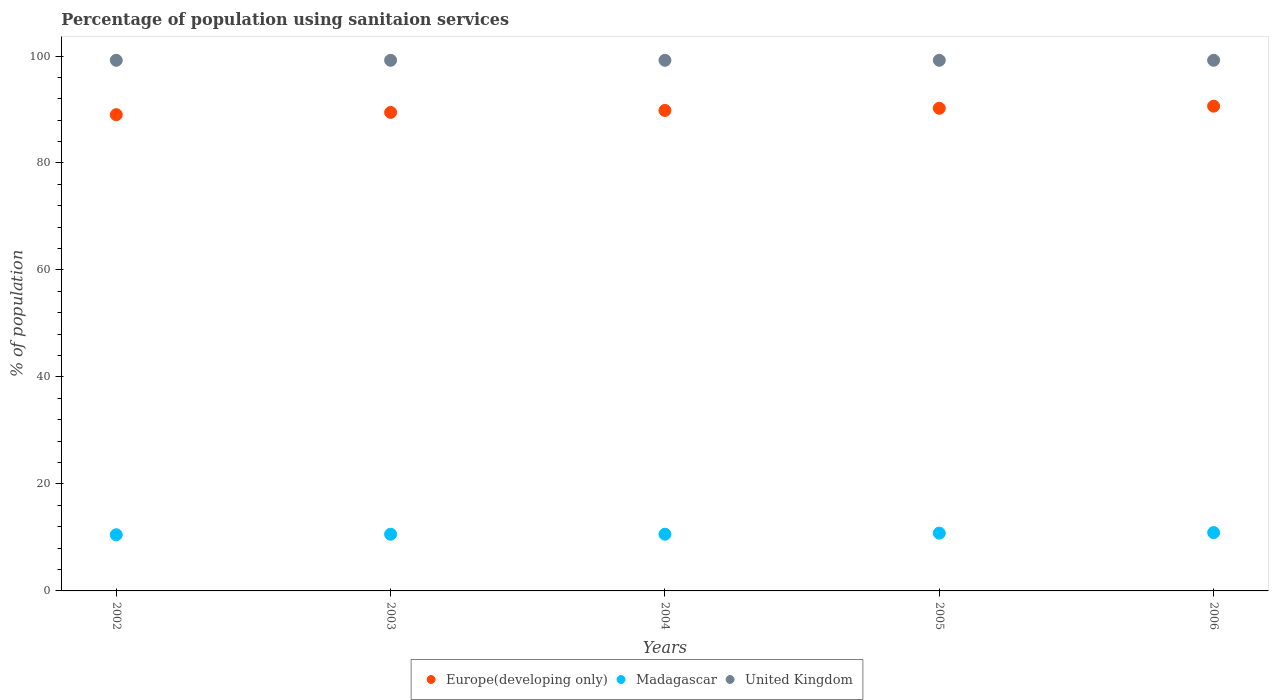How many different coloured dotlines are there?
Your answer should be very brief. 3. What is the percentage of population using sanitaion services in United Kingdom in 2006?
Give a very brief answer. 99.2. Across all years, what is the maximum percentage of population using sanitaion services in Europe(developing only)?
Your response must be concise. 90.63. Across all years, what is the minimum percentage of population using sanitaion services in Europe(developing only)?
Offer a very short reply. 89.03. In which year was the percentage of population using sanitaion services in Madagascar minimum?
Your answer should be compact. 2002. What is the total percentage of population using sanitaion services in United Kingdom in the graph?
Offer a very short reply. 496. What is the difference between the percentage of population using sanitaion services in Madagascar in 2002 and that in 2004?
Keep it short and to the point. -0.1. What is the difference between the percentage of population using sanitaion services in Europe(developing only) in 2006 and the percentage of population using sanitaion services in Madagascar in 2004?
Give a very brief answer. 80.03. What is the average percentage of population using sanitaion services in Madagascar per year?
Your answer should be very brief. 10.68. In the year 2006, what is the difference between the percentage of population using sanitaion services in Madagascar and percentage of population using sanitaion services in Europe(developing only)?
Make the answer very short. -79.73. What is the ratio of the percentage of population using sanitaion services in Madagascar in 2004 to that in 2005?
Make the answer very short. 0.98. Is the percentage of population using sanitaion services in Europe(developing only) in 2003 less than that in 2004?
Give a very brief answer. Yes. Is the difference between the percentage of population using sanitaion services in Madagascar in 2002 and 2006 greater than the difference between the percentage of population using sanitaion services in Europe(developing only) in 2002 and 2006?
Provide a short and direct response. Yes. What is the difference between the highest and the second highest percentage of population using sanitaion services in Europe(developing only)?
Ensure brevity in your answer.  0.4. What is the difference between the highest and the lowest percentage of population using sanitaion services in Madagascar?
Ensure brevity in your answer.  0.4. Is the sum of the percentage of population using sanitaion services in Madagascar in 2004 and 2005 greater than the maximum percentage of population using sanitaion services in Europe(developing only) across all years?
Your response must be concise. No. Does the percentage of population using sanitaion services in Europe(developing only) monotonically increase over the years?
Keep it short and to the point. Yes. Is the percentage of population using sanitaion services in Madagascar strictly greater than the percentage of population using sanitaion services in Europe(developing only) over the years?
Keep it short and to the point. No. Is the percentage of population using sanitaion services in United Kingdom strictly less than the percentage of population using sanitaion services in Madagascar over the years?
Give a very brief answer. No. How many years are there in the graph?
Offer a terse response. 5. Are the values on the major ticks of Y-axis written in scientific E-notation?
Give a very brief answer. No. Does the graph contain any zero values?
Keep it short and to the point. No. Where does the legend appear in the graph?
Offer a very short reply. Bottom center. How are the legend labels stacked?
Provide a succinct answer. Horizontal. What is the title of the graph?
Provide a succinct answer. Percentage of population using sanitaion services. What is the label or title of the Y-axis?
Your answer should be very brief. % of population. What is the % of population in Europe(developing only) in 2002?
Ensure brevity in your answer.  89.03. What is the % of population of Madagascar in 2002?
Give a very brief answer. 10.5. What is the % of population of United Kingdom in 2002?
Ensure brevity in your answer.  99.2. What is the % of population of Europe(developing only) in 2003?
Provide a succinct answer. 89.46. What is the % of population of United Kingdom in 2003?
Give a very brief answer. 99.2. What is the % of population in Europe(developing only) in 2004?
Your answer should be very brief. 89.83. What is the % of population of Madagascar in 2004?
Provide a succinct answer. 10.6. What is the % of population of United Kingdom in 2004?
Keep it short and to the point. 99.2. What is the % of population in Europe(developing only) in 2005?
Provide a short and direct response. 90.23. What is the % of population in Madagascar in 2005?
Keep it short and to the point. 10.8. What is the % of population in United Kingdom in 2005?
Provide a short and direct response. 99.2. What is the % of population of Europe(developing only) in 2006?
Give a very brief answer. 90.63. What is the % of population of Madagascar in 2006?
Provide a succinct answer. 10.9. What is the % of population in United Kingdom in 2006?
Give a very brief answer. 99.2. Across all years, what is the maximum % of population in Europe(developing only)?
Keep it short and to the point. 90.63. Across all years, what is the maximum % of population in United Kingdom?
Your answer should be very brief. 99.2. Across all years, what is the minimum % of population in Europe(developing only)?
Give a very brief answer. 89.03. Across all years, what is the minimum % of population in United Kingdom?
Ensure brevity in your answer.  99.2. What is the total % of population in Europe(developing only) in the graph?
Offer a terse response. 449.17. What is the total % of population of Madagascar in the graph?
Ensure brevity in your answer.  53.4. What is the total % of population in United Kingdom in the graph?
Make the answer very short. 496. What is the difference between the % of population in Europe(developing only) in 2002 and that in 2003?
Your response must be concise. -0.42. What is the difference between the % of population of United Kingdom in 2002 and that in 2003?
Keep it short and to the point. 0. What is the difference between the % of population in Europe(developing only) in 2002 and that in 2004?
Make the answer very short. -0.79. What is the difference between the % of population in Europe(developing only) in 2002 and that in 2005?
Give a very brief answer. -1.2. What is the difference between the % of population in United Kingdom in 2002 and that in 2005?
Offer a terse response. 0. What is the difference between the % of population of Europe(developing only) in 2002 and that in 2006?
Your answer should be compact. -1.59. What is the difference between the % of population of Europe(developing only) in 2003 and that in 2004?
Offer a terse response. -0.37. What is the difference between the % of population of Madagascar in 2003 and that in 2004?
Offer a terse response. 0. What is the difference between the % of population in Europe(developing only) in 2003 and that in 2005?
Keep it short and to the point. -0.77. What is the difference between the % of population in Madagascar in 2003 and that in 2005?
Provide a short and direct response. -0.2. What is the difference between the % of population of United Kingdom in 2003 and that in 2005?
Offer a very short reply. 0. What is the difference between the % of population in Europe(developing only) in 2003 and that in 2006?
Offer a terse response. -1.17. What is the difference between the % of population in Madagascar in 2003 and that in 2006?
Provide a short and direct response. -0.3. What is the difference between the % of population in Europe(developing only) in 2004 and that in 2005?
Make the answer very short. -0.4. What is the difference between the % of population in Madagascar in 2004 and that in 2005?
Offer a very short reply. -0.2. What is the difference between the % of population of United Kingdom in 2004 and that in 2005?
Make the answer very short. 0. What is the difference between the % of population of Europe(developing only) in 2004 and that in 2006?
Make the answer very short. -0.8. What is the difference between the % of population in Madagascar in 2004 and that in 2006?
Offer a very short reply. -0.3. What is the difference between the % of population in Europe(developing only) in 2005 and that in 2006?
Keep it short and to the point. -0.4. What is the difference between the % of population in Madagascar in 2005 and that in 2006?
Ensure brevity in your answer.  -0.1. What is the difference between the % of population of United Kingdom in 2005 and that in 2006?
Your answer should be compact. 0. What is the difference between the % of population of Europe(developing only) in 2002 and the % of population of Madagascar in 2003?
Provide a short and direct response. 78.43. What is the difference between the % of population in Europe(developing only) in 2002 and the % of population in United Kingdom in 2003?
Offer a very short reply. -10.17. What is the difference between the % of population of Madagascar in 2002 and the % of population of United Kingdom in 2003?
Your answer should be very brief. -88.7. What is the difference between the % of population in Europe(developing only) in 2002 and the % of population in Madagascar in 2004?
Offer a very short reply. 78.43. What is the difference between the % of population in Europe(developing only) in 2002 and the % of population in United Kingdom in 2004?
Your answer should be very brief. -10.17. What is the difference between the % of population in Madagascar in 2002 and the % of population in United Kingdom in 2004?
Provide a short and direct response. -88.7. What is the difference between the % of population in Europe(developing only) in 2002 and the % of population in Madagascar in 2005?
Your answer should be very brief. 78.23. What is the difference between the % of population of Europe(developing only) in 2002 and the % of population of United Kingdom in 2005?
Make the answer very short. -10.17. What is the difference between the % of population in Madagascar in 2002 and the % of population in United Kingdom in 2005?
Your answer should be compact. -88.7. What is the difference between the % of population of Europe(developing only) in 2002 and the % of population of Madagascar in 2006?
Offer a terse response. 78.13. What is the difference between the % of population in Europe(developing only) in 2002 and the % of population in United Kingdom in 2006?
Ensure brevity in your answer.  -10.17. What is the difference between the % of population in Madagascar in 2002 and the % of population in United Kingdom in 2006?
Your answer should be compact. -88.7. What is the difference between the % of population of Europe(developing only) in 2003 and the % of population of Madagascar in 2004?
Your answer should be very brief. 78.86. What is the difference between the % of population in Europe(developing only) in 2003 and the % of population in United Kingdom in 2004?
Provide a succinct answer. -9.74. What is the difference between the % of population in Madagascar in 2003 and the % of population in United Kingdom in 2004?
Provide a short and direct response. -88.6. What is the difference between the % of population of Europe(developing only) in 2003 and the % of population of Madagascar in 2005?
Your answer should be very brief. 78.66. What is the difference between the % of population in Europe(developing only) in 2003 and the % of population in United Kingdom in 2005?
Your response must be concise. -9.74. What is the difference between the % of population in Madagascar in 2003 and the % of population in United Kingdom in 2005?
Your answer should be compact. -88.6. What is the difference between the % of population in Europe(developing only) in 2003 and the % of population in Madagascar in 2006?
Keep it short and to the point. 78.56. What is the difference between the % of population of Europe(developing only) in 2003 and the % of population of United Kingdom in 2006?
Offer a very short reply. -9.74. What is the difference between the % of population of Madagascar in 2003 and the % of population of United Kingdom in 2006?
Make the answer very short. -88.6. What is the difference between the % of population of Europe(developing only) in 2004 and the % of population of Madagascar in 2005?
Give a very brief answer. 79.03. What is the difference between the % of population in Europe(developing only) in 2004 and the % of population in United Kingdom in 2005?
Your answer should be compact. -9.37. What is the difference between the % of population of Madagascar in 2004 and the % of population of United Kingdom in 2005?
Your answer should be very brief. -88.6. What is the difference between the % of population in Europe(developing only) in 2004 and the % of population in Madagascar in 2006?
Your answer should be very brief. 78.93. What is the difference between the % of population in Europe(developing only) in 2004 and the % of population in United Kingdom in 2006?
Offer a very short reply. -9.37. What is the difference between the % of population of Madagascar in 2004 and the % of population of United Kingdom in 2006?
Your answer should be compact. -88.6. What is the difference between the % of population of Europe(developing only) in 2005 and the % of population of Madagascar in 2006?
Offer a very short reply. 79.33. What is the difference between the % of population of Europe(developing only) in 2005 and the % of population of United Kingdom in 2006?
Your response must be concise. -8.97. What is the difference between the % of population of Madagascar in 2005 and the % of population of United Kingdom in 2006?
Offer a terse response. -88.4. What is the average % of population in Europe(developing only) per year?
Your answer should be very brief. 89.83. What is the average % of population in Madagascar per year?
Provide a short and direct response. 10.68. What is the average % of population in United Kingdom per year?
Ensure brevity in your answer.  99.2. In the year 2002, what is the difference between the % of population in Europe(developing only) and % of population in Madagascar?
Offer a very short reply. 78.53. In the year 2002, what is the difference between the % of population of Europe(developing only) and % of population of United Kingdom?
Keep it short and to the point. -10.17. In the year 2002, what is the difference between the % of population in Madagascar and % of population in United Kingdom?
Keep it short and to the point. -88.7. In the year 2003, what is the difference between the % of population of Europe(developing only) and % of population of Madagascar?
Provide a succinct answer. 78.86. In the year 2003, what is the difference between the % of population in Europe(developing only) and % of population in United Kingdom?
Make the answer very short. -9.74. In the year 2003, what is the difference between the % of population in Madagascar and % of population in United Kingdom?
Make the answer very short. -88.6. In the year 2004, what is the difference between the % of population of Europe(developing only) and % of population of Madagascar?
Your response must be concise. 79.23. In the year 2004, what is the difference between the % of population in Europe(developing only) and % of population in United Kingdom?
Keep it short and to the point. -9.37. In the year 2004, what is the difference between the % of population in Madagascar and % of population in United Kingdom?
Offer a terse response. -88.6. In the year 2005, what is the difference between the % of population in Europe(developing only) and % of population in Madagascar?
Your response must be concise. 79.43. In the year 2005, what is the difference between the % of population of Europe(developing only) and % of population of United Kingdom?
Your answer should be compact. -8.97. In the year 2005, what is the difference between the % of population of Madagascar and % of population of United Kingdom?
Give a very brief answer. -88.4. In the year 2006, what is the difference between the % of population of Europe(developing only) and % of population of Madagascar?
Offer a terse response. 79.73. In the year 2006, what is the difference between the % of population in Europe(developing only) and % of population in United Kingdom?
Your response must be concise. -8.57. In the year 2006, what is the difference between the % of population in Madagascar and % of population in United Kingdom?
Ensure brevity in your answer.  -88.3. What is the ratio of the % of population in Europe(developing only) in 2002 to that in 2003?
Offer a very short reply. 1. What is the ratio of the % of population in Madagascar in 2002 to that in 2003?
Provide a succinct answer. 0.99. What is the ratio of the % of population in Madagascar in 2002 to that in 2004?
Offer a terse response. 0.99. What is the ratio of the % of population in Europe(developing only) in 2002 to that in 2005?
Provide a short and direct response. 0.99. What is the ratio of the % of population in Madagascar in 2002 to that in 2005?
Offer a terse response. 0.97. What is the ratio of the % of population of United Kingdom in 2002 to that in 2005?
Provide a short and direct response. 1. What is the ratio of the % of population in Europe(developing only) in 2002 to that in 2006?
Your response must be concise. 0.98. What is the ratio of the % of population of Madagascar in 2002 to that in 2006?
Your answer should be very brief. 0.96. What is the ratio of the % of population of Europe(developing only) in 2003 to that in 2004?
Offer a very short reply. 1. What is the ratio of the % of population of Europe(developing only) in 2003 to that in 2005?
Keep it short and to the point. 0.99. What is the ratio of the % of population in Madagascar in 2003 to that in 2005?
Make the answer very short. 0.98. What is the ratio of the % of population of Europe(developing only) in 2003 to that in 2006?
Ensure brevity in your answer.  0.99. What is the ratio of the % of population of Madagascar in 2003 to that in 2006?
Keep it short and to the point. 0.97. What is the ratio of the % of population of United Kingdom in 2003 to that in 2006?
Make the answer very short. 1. What is the ratio of the % of population of Madagascar in 2004 to that in 2005?
Give a very brief answer. 0.98. What is the ratio of the % of population in Europe(developing only) in 2004 to that in 2006?
Keep it short and to the point. 0.99. What is the ratio of the % of population of Madagascar in 2004 to that in 2006?
Give a very brief answer. 0.97. What is the ratio of the % of population of Madagascar in 2005 to that in 2006?
Make the answer very short. 0.99. What is the difference between the highest and the second highest % of population in Europe(developing only)?
Offer a very short reply. 0.4. What is the difference between the highest and the lowest % of population of Europe(developing only)?
Provide a succinct answer. 1.59. What is the difference between the highest and the lowest % of population of Madagascar?
Provide a short and direct response. 0.4. What is the difference between the highest and the lowest % of population of United Kingdom?
Offer a terse response. 0. 